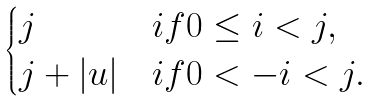Convert formula to latex. <formula><loc_0><loc_0><loc_500><loc_500>\begin{cases} j & i f 0 \leq i < j , \\ j + | u | & i f 0 < - i < j . \end{cases}</formula> 